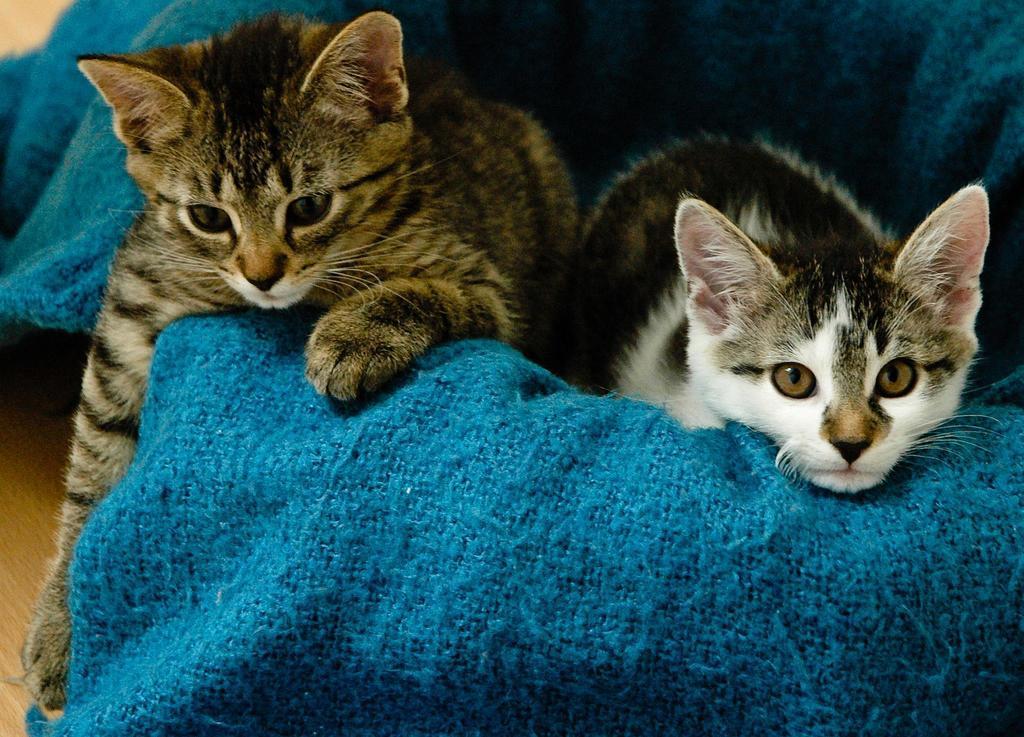Could you give a brief overview of what you see in this image? In the center of the image two cats are present. In the background of the image cloth is there. At the bottom of the image floor is present. 